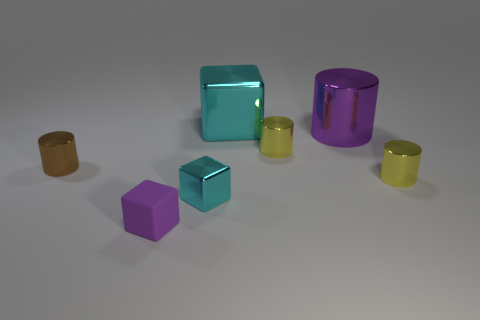How big is the purple cylinder?
Provide a succinct answer. Large. There is a purple metallic object that is the same shape as the brown object; what is its size?
Provide a succinct answer. Large. There is a cyan object that is behind the tiny cyan metallic block; how many big shiny things are to the left of it?
Keep it short and to the point. 0. Do the tiny cube on the right side of the small rubber block and the small object that is in front of the small cyan metallic object have the same material?
Keep it short and to the point. No. How many big cyan objects have the same shape as the big purple shiny thing?
Offer a terse response. 0. What number of tiny shiny things have the same color as the big metal cube?
Offer a very short reply. 1. There is a object that is behind the large purple object; is its shape the same as the purple thing that is on the left side of the purple cylinder?
Your answer should be compact. Yes. There is a cyan shiny thing that is in front of the thing behind the big shiny cylinder; how many large purple metallic cylinders are behind it?
Give a very brief answer. 1. What is the purple thing in front of the cylinder that is on the left side of the yellow object that is behind the tiny brown thing made of?
Provide a succinct answer. Rubber. Does the block that is behind the small cyan block have the same material as the tiny cyan thing?
Offer a very short reply. Yes. 